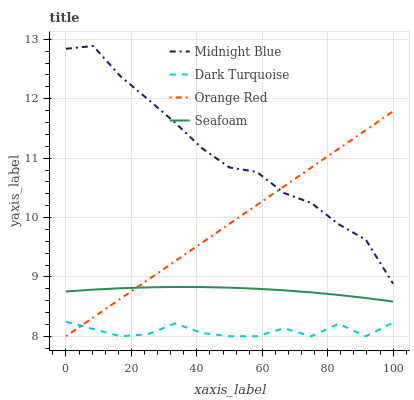Does Dark Turquoise have the minimum area under the curve?
Answer yes or no. Yes. Does Midnight Blue have the maximum area under the curve?
Answer yes or no. Yes. Does Seafoam have the minimum area under the curve?
Answer yes or no. No. Does Seafoam have the maximum area under the curve?
Answer yes or no. No. Is Orange Red the smoothest?
Answer yes or no. Yes. Is Dark Turquoise the roughest?
Answer yes or no. Yes. Is Seafoam the smoothest?
Answer yes or no. No. Is Seafoam the roughest?
Answer yes or no. No. Does Seafoam have the lowest value?
Answer yes or no. No. Does Midnight Blue have the highest value?
Answer yes or no. Yes. Does Seafoam have the highest value?
Answer yes or no. No. Is Seafoam less than Midnight Blue?
Answer yes or no. Yes. Is Seafoam greater than Dark Turquoise?
Answer yes or no. Yes. Does Orange Red intersect Seafoam?
Answer yes or no. Yes. Is Orange Red less than Seafoam?
Answer yes or no. No. Is Orange Red greater than Seafoam?
Answer yes or no. No. Does Seafoam intersect Midnight Blue?
Answer yes or no. No. 